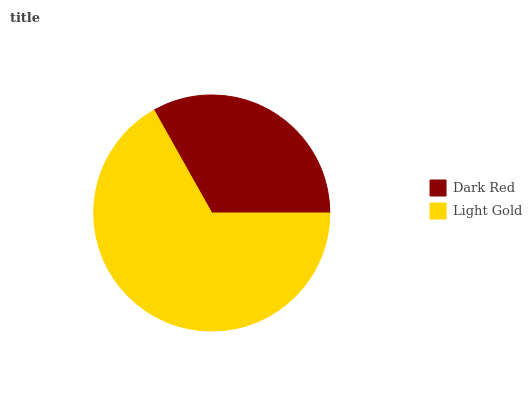Is Dark Red the minimum?
Answer yes or no. Yes. Is Light Gold the maximum?
Answer yes or no. Yes. Is Light Gold the minimum?
Answer yes or no. No. Is Light Gold greater than Dark Red?
Answer yes or no. Yes. Is Dark Red less than Light Gold?
Answer yes or no. Yes. Is Dark Red greater than Light Gold?
Answer yes or no. No. Is Light Gold less than Dark Red?
Answer yes or no. No. Is Light Gold the high median?
Answer yes or no. Yes. Is Dark Red the low median?
Answer yes or no. Yes. Is Dark Red the high median?
Answer yes or no. No. Is Light Gold the low median?
Answer yes or no. No. 